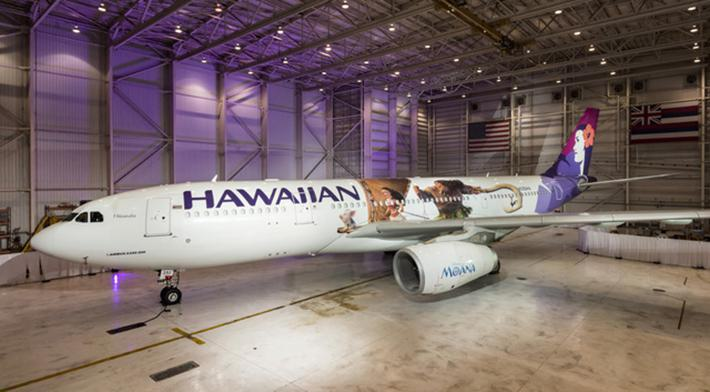Can you describe the setting where this airplane is located? The airplane is inside a spacious hangar, which is typically used for maintenance, repair, or storage of aircraft. The setting includes ample lighting, and the hangar doors are closed. There is maintenance equipment visible, suggesting that the plane might be undergoing a routine check or service work. 